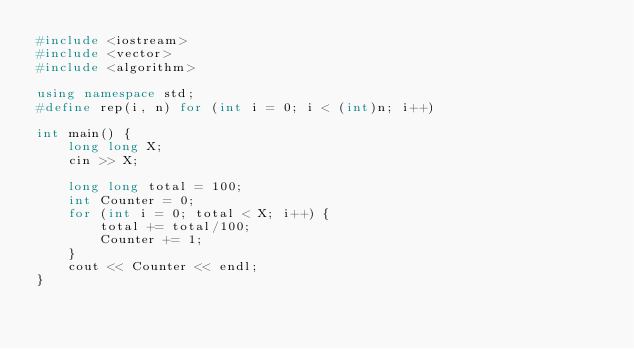Convert code to text. <code><loc_0><loc_0><loc_500><loc_500><_C++_>#include <iostream> 
#include <vector>
#include <algorithm>

using namespace std;
#define rep(i, n) for (int i = 0; i < (int)n; i++) 

int main() {
    long long X;
    cin >> X;
    
    long long total = 100;
    int Counter = 0;
    for (int i = 0; total < X; i++) {
        total += total/100;
        Counter += 1;
    }
    cout << Counter << endl;
}
</code> 